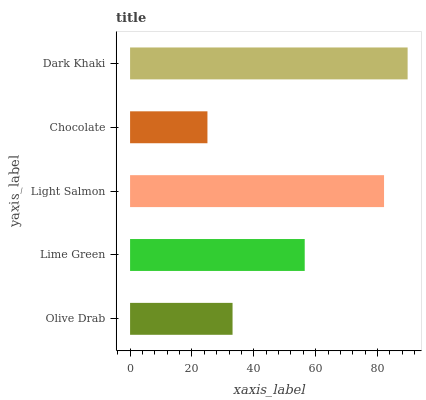Is Chocolate the minimum?
Answer yes or no. Yes. Is Dark Khaki the maximum?
Answer yes or no. Yes. Is Lime Green the minimum?
Answer yes or no. No. Is Lime Green the maximum?
Answer yes or no. No. Is Lime Green greater than Olive Drab?
Answer yes or no. Yes. Is Olive Drab less than Lime Green?
Answer yes or no. Yes. Is Olive Drab greater than Lime Green?
Answer yes or no. No. Is Lime Green less than Olive Drab?
Answer yes or no. No. Is Lime Green the high median?
Answer yes or no. Yes. Is Lime Green the low median?
Answer yes or no. Yes. Is Chocolate the high median?
Answer yes or no. No. Is Light Salmon the low median?
Answer yes or no. No. 